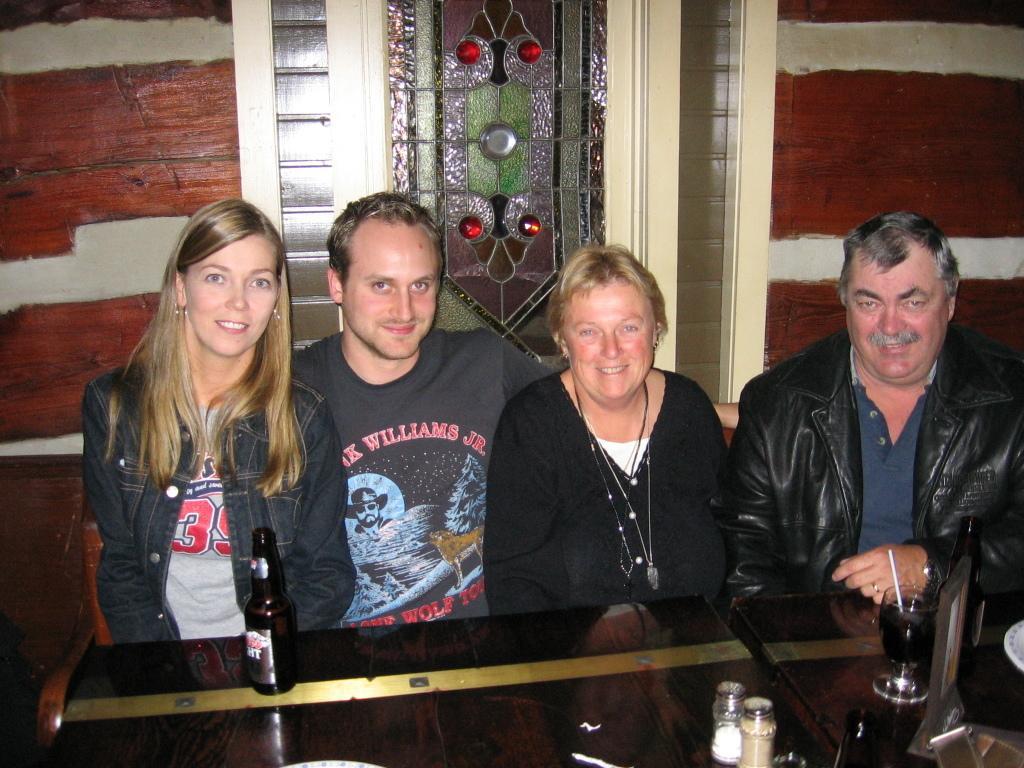How would you summarize this image in a sentence or two? In this image there are four people sitting in front of the table with a smile on their face. On the table there is a bottle, glass of drink with straw and some other objects. 